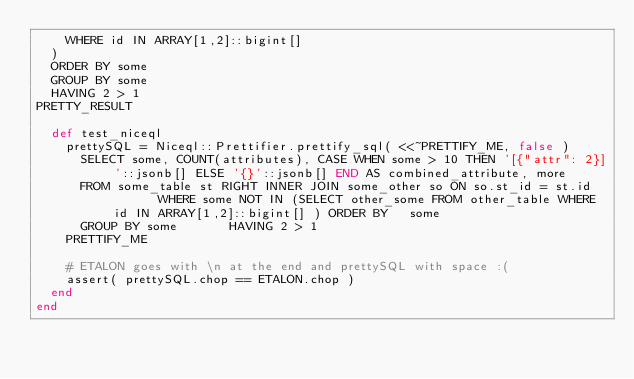<code> <loc_0><loc_0><loc_500><loc_500><_Ruby_>    WHERE id IN ARRAY[1,2]::bigint[] 
  ) 
  ORDER BY some 
  GROUP BY some 
  HAVING 2 > 1
PRETTY_RESULT

  def test_niceql
    prettySQL = Niceql::Prettifier.prettify_sql( <<~PRETTIFY_ME, false )
      SELECT some, COUNT(attributes), CASE WHEN some > 10 THEN '[{"attr": 2}]'::jsonb[] ELSE '{}'::jsonb[] END AS combined_attribute, more 
      FROM some_table st RIGHT INNER JOIN some_other so ON so.st_id = st.id       WHERE some NOT IN (SELECT other_some FROM other_table WHERE id IN ARRAY[1,2]::bigint[] ) ORDER BY   some
      GROUP BY some       HAVING 2 > 1
    PRETTIFY_ME

    # ETALON goes with \n at the end and prettySQL with space :(
    assert( prettySQL.chop == ETALON.chop )
  end
end
</code> 